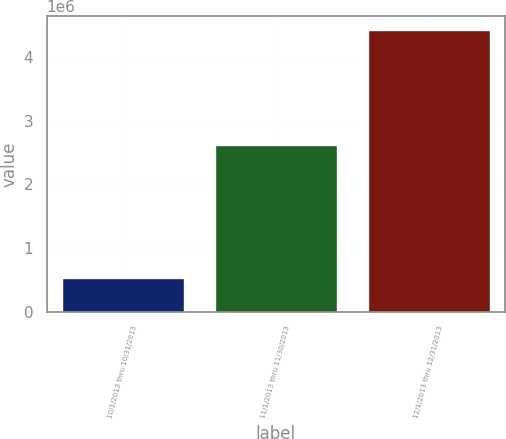Convert chart to OTSL. <chart><loc_0><loc_0><loc_500><loc_500><bar_chart><fcel>10/1/2013 thru 10/31/2013<fcel>11/1/2013 thru 11/30/2013<fcel>12/1/2013 thru 12/31/2013<nl><fcel>536500<fcel>2.61528e+06<fcel>4.41837e+06<nl></chart> 